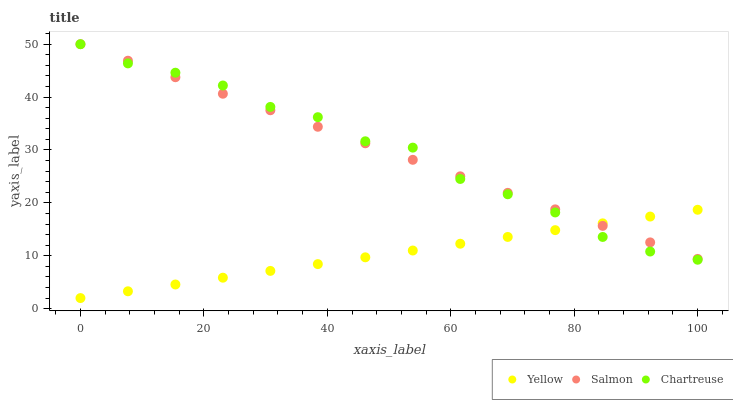Does Yellow have the minimum area under the curve?
Answer yes or no. Yes. Does Chartreuse have the maximum area under the curve?
Answer yes or no. Yes. Does Salmon have the minimum area under the curve?
Answer yes or no. No. Does Salmon have the maximum area under the curve?
Answer yes or no. No. Is Yellow the smoothest?
Answer yes or no. Yes. Is Chartreuse the roughest?
Answer yes or no. Yes. Is Salmon the smoothest?
Answer yes or no. No. Is Salmon the roughest?
Answer yes or no. No. Does Yellow have the lowest value?
Answer yes or no. Yes. Does Salmon have the lowest value?
Answer yes or no. No. Does Salmon have the highest value?
Answer yes or no. Yes. Does Yellow have the highest value?
Answer yes or no. No. Does Yellow intersect Chartreuse?
Answer yes or no. Yes. Is Yellow less than Chartreuse?
Answer yes or no. No. Is Yellow greater than Chartreuse?
Answer yes or no. No. 